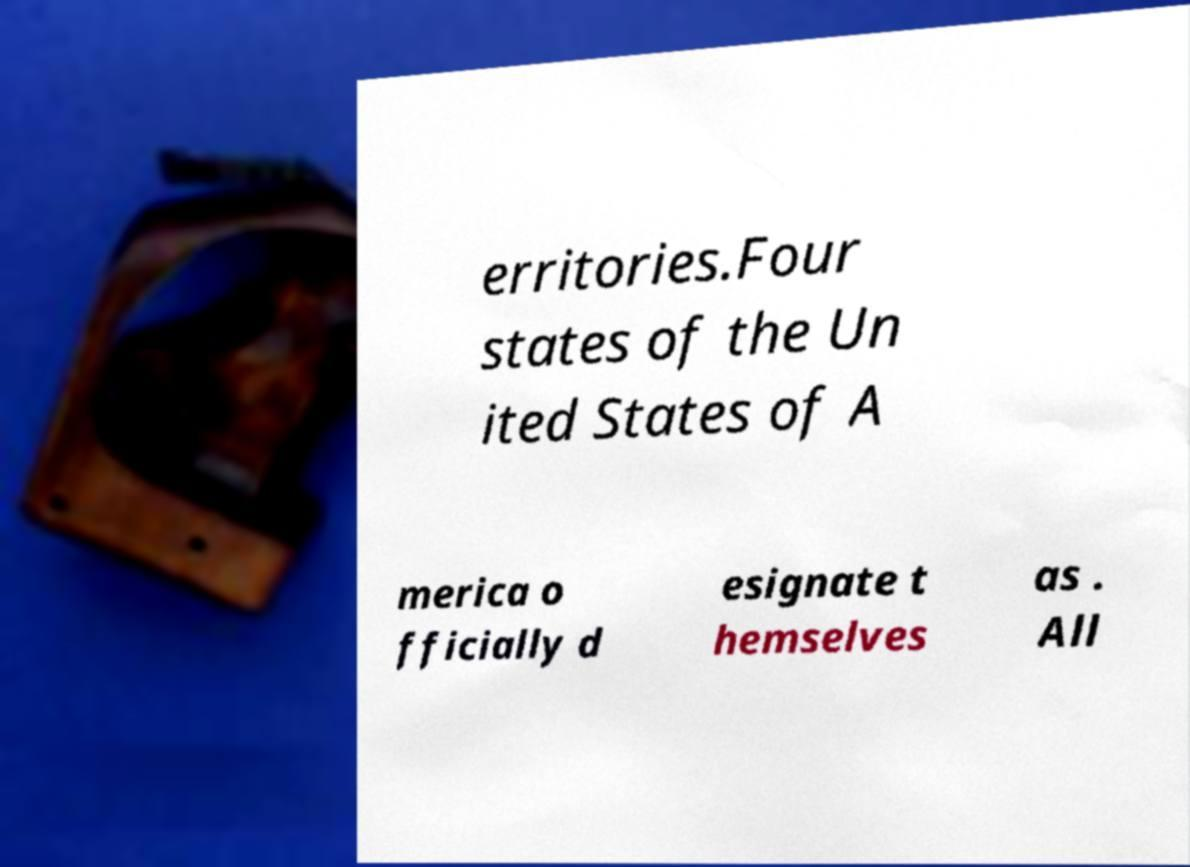What messages or text are displayed in this image? I need them in a readable, typed format. erritories.Four states of the Un ited States of A merica o fficially d esignate t hemselves as . All 